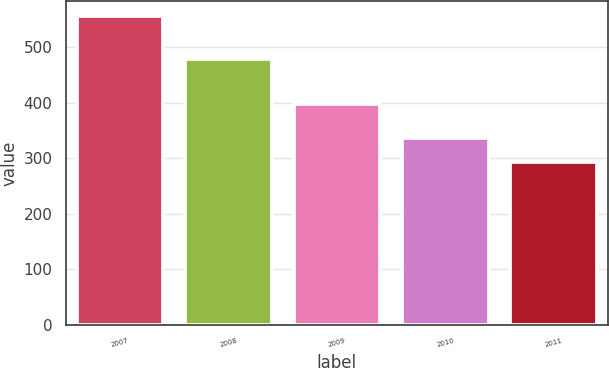Convert chart. <chart><loc_0><loc_0><loc_500><loc_500><bar_chart><fcel>2007<fcel>2008<fcel>2009<fcel>2010<fcel>2011<nl><fcel>555<fcel>479<fcel>397<fcel>336<fcel>293<nl></chart> 